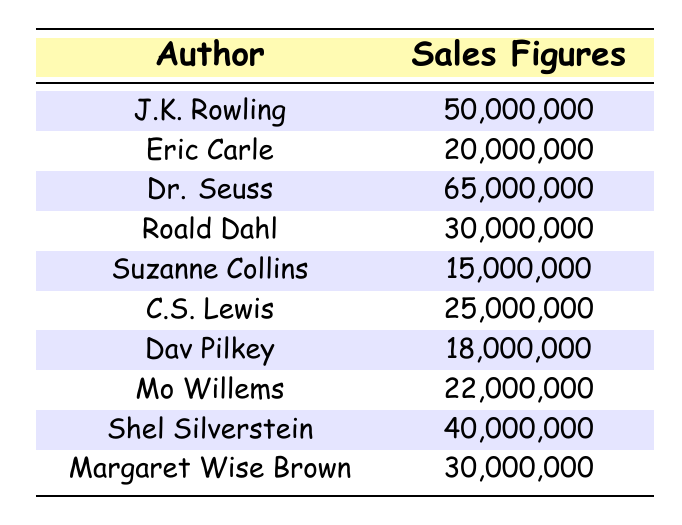What is the highest sales figure recorded in the table? By reviewing the sales figures listed, I can see that Dr. Seuss has the highest sales figure of 65,000,000.
Answer: 65,000,000 How many authors have sales figures greater than 30,000,000? The authors with sales greater than 30,000,000 are J.K. Rowling (50,000,000), Dr. Seuss (65,000,000), Shel Silverstein (40,000,000), and Margaret Wise Brown (30,000,000). This makes a total of four authors.
Answer: 4 What is the total sales figure of all authors listed? To find the total, I add each author's sales figure: 50,000,000 + 20,000,000 + 65,000,000 + 30,000,000 + 15,000,000 + 25,000,000 + 18,000,000 + 22,000,000 + 40,000,000 + 30,000,000 =  315,000,000.
Answer: 315,000,000 Is there any author with sales figures less than 20,000,000? By examining the table, I see that Suzanne Collins has a sales figure of 15,000,000, which is indeed less than 20,000,000.
Answer: Yes What is the average sales figure of the authors listed? To calculate the average, I first find the total sales figure (which is 315,000,000) and divide by the number of authors (10). Therefore, 315,000,000 / 10 = 31,500,000.
Answer: 31,500,000 How many authors have sales figures between 20,000,000 and 30,000,000? I check and find the following authors in that range: Eric Carle (20,000,000), C.S. Lewis (25,000,000), and Roald Dahl (30,000,000). This gives us a total of three authors.
Answer: 3 Which author has sales closer to 20,000,000, Eric Carle or Mo Willems? Eric Carle has 20,000,000 and Mo Willems has 22,000,000. The difference is 2,000,000 for Mo Willems and 0 for Eric Carle, making Eric Carle closer to 20,000,000.
Answer: Eric Carle What is the median sales figure among all authors? To find the median, I list the sales figures in order: 15,000,000, 18,000,000, 20,000,000, 22,000,000, 25,000,000, 30,000,000, 30,000,000, 40,000,000, 50,000,000, 65,000,000. Since there are 10 figures, the median will be the average of the 5th and 6th values (25,000,000 and 30,000,000). The median is (25,000,000 + 30,000,000) / 2 = 27,500,000.
Answer: 27,500,000 